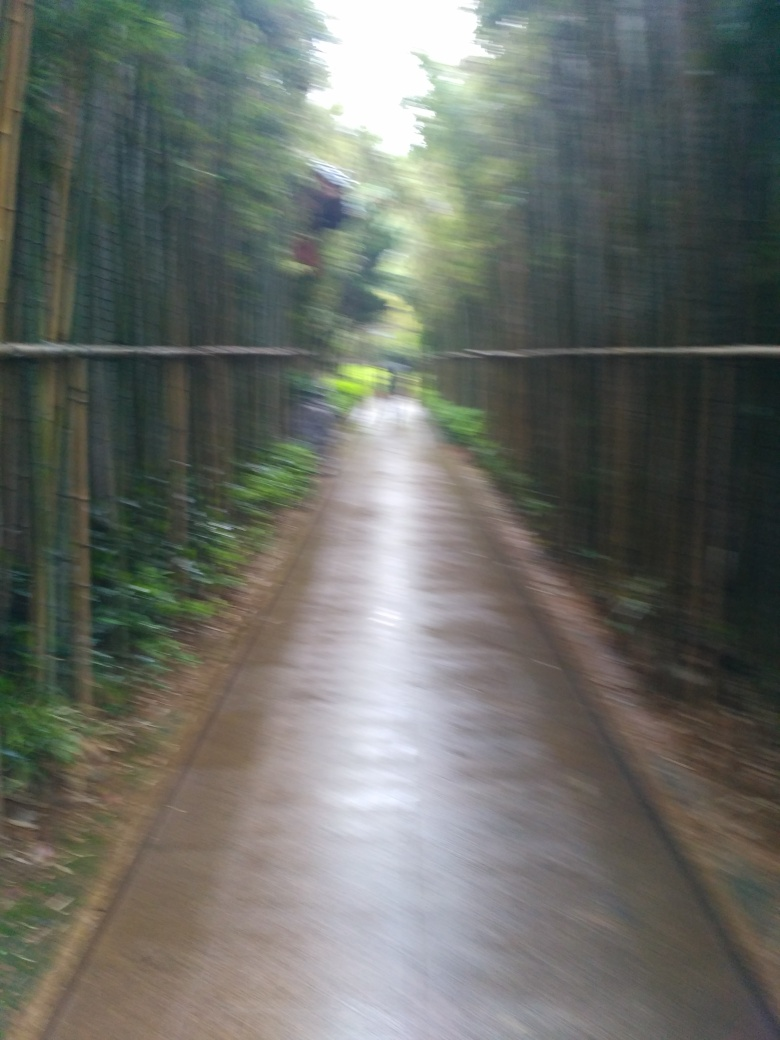The bamboo seems really dense. What can you tell me about the ecological significance of bamboo? Bamboo is an incredibly significant plant ecologically. It grows rapidly and is a critical element in the balance of oxygen and carbon dioxide in the atmosphere. Bamboo forests also provide habitat for a variety of species, prevent soil erosion, and are a renewable resource for building material, among other uses. 